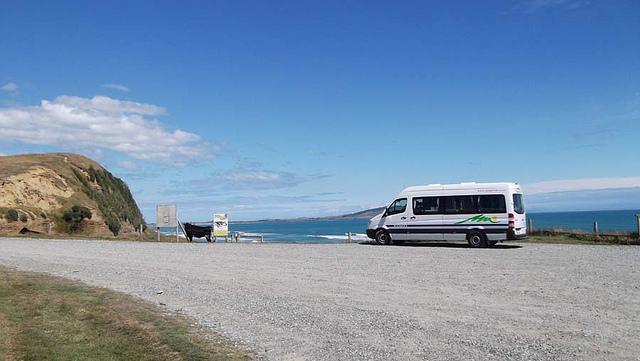How many faces of the clock can you see completely?
Give a very brief answer. 0. 